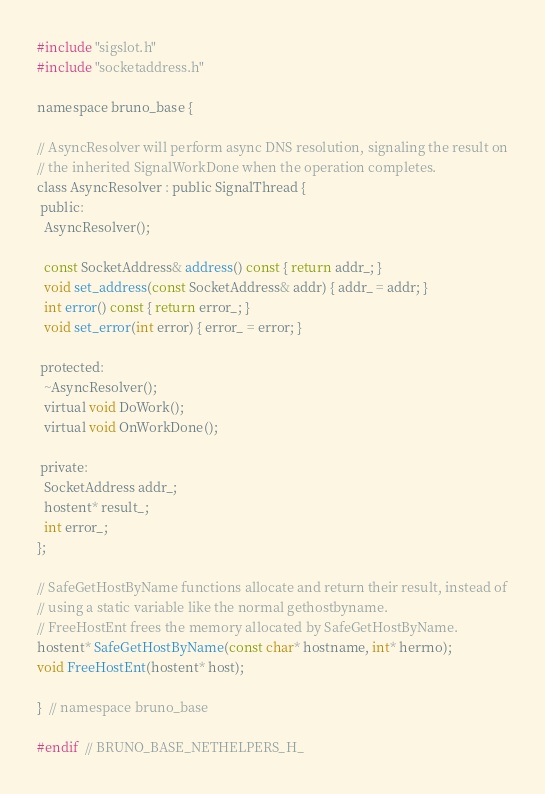Convert code to text. <code><loc_0><loc_0><loc_500><loc_500><_C_>#include "sigslot.h"
#include "socketaddress.h"

namespace bruno_base {

// AsyncResolver will perform async DNS resolution, signaling the result on
// the inherited SignalWorkDone when the operation completes.
class AsyncResolver : public SignalThread {
 public:
  AsyncResolver();

  const SocketAddress& address() const { return addr_; }
  void set_address(const SocketAddress& addr) { addr_ = addr; }
  int error() const { return error_; }
  void set_error(int error) { error_ = error; }

 protected:
  ~AsyncResolver();
  virtual void DoWork();
  virtual void OnWorkDone();

 private:
  SocketAddress addr_;
  hostent* result_;
  int error_;
};

// SafeGetHostByName functions allocate and return their result, instead of
// using a static variable like the normal gethostbyname.
// FreeHostEnt frees the memory allocated by SafeGetHostByName.
hostent* SafeGetHostByName(const char* hostname, int* herrno);
void FreeHostEnt(hostent* host);

}  // namespace bruno_base

#endif  // BRUNO_BASE_NETHELPERS_H_
</code> 